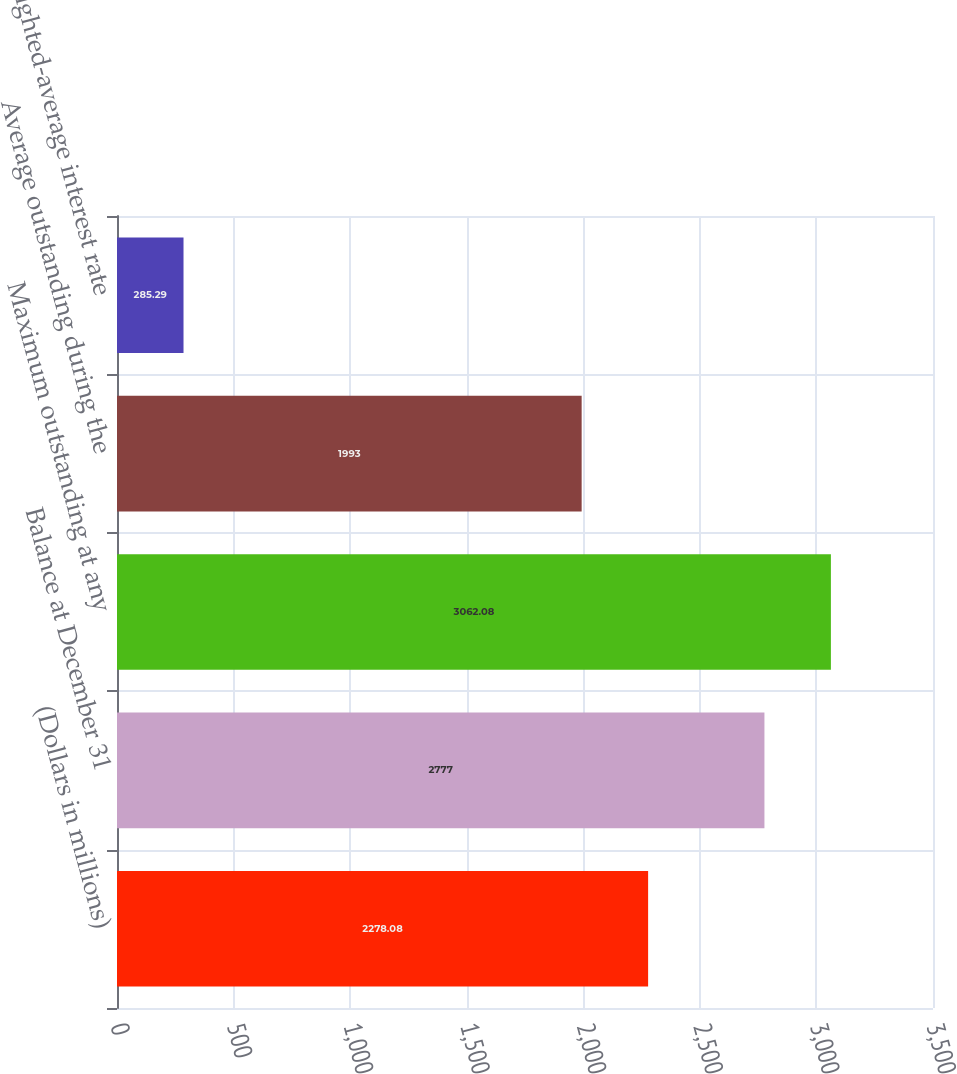<chart> <loc_0><loc_0><loc_500><loc_500><bar_chart><fcel>(Dollars in millions)<fcel>Balance at December 31<fcel>Maximum outstanding at any<fcel>Average outstanding during the<fcel>Weighted-average interest rate<nl><fcel>2278.08<fcel>2777<fcel>3062.08<fcel>1993<fcel>285.29<nl></chart> 